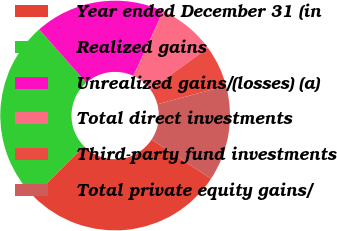<chart> <loc_0><loc_0><loc_500><loc_500><pie_chart><fcel>Year ended December 31 (in<fcel>Realized gains<fcel>Unrealized gains/(losses) (a)<fcel>Total direct investments<fcel>Third-party fund investments<fcel>Total private equity gains/<nl><fcel>28.3%<fcel>25.92%<fcel>18.37%<fcel>8.11%<fcel>5.87%<fcel>13.43%<nl></chart> 